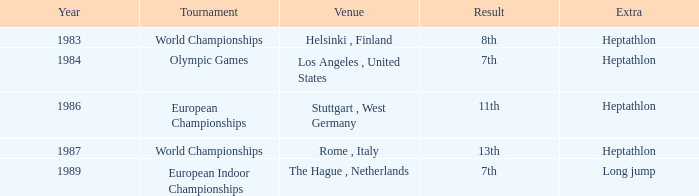Give me the full table as a dictionary. {'header': ['Year', 'Tournament', 'Venue', 'Result', 'Extra'], 'rows': [['1983', 'World Championships', 'Helsinki , Finland', '8th', 'Heptathlon'], ['1984', 'Olympic Games', 'Los Angeles , United States', '7th', 'Heptathlon'], ['1986', 'European Championships', 'Stuttgart , West Germany', '11th', 'Heptathlon'], ['1987', 'World Championships', 'Rome , Italy', '13th', 'Heptathlon'], ['1989', 'European Indoor Championships', 'The Hague , Netherlands', '7th', 'Long jump']]} How often are the Olympic games hosted? 1984.0. 